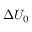Convert formula to latex. <formula><loc_0><loc_0><loc_500><loc_500>\Delta U _ { 0 }</formula> 